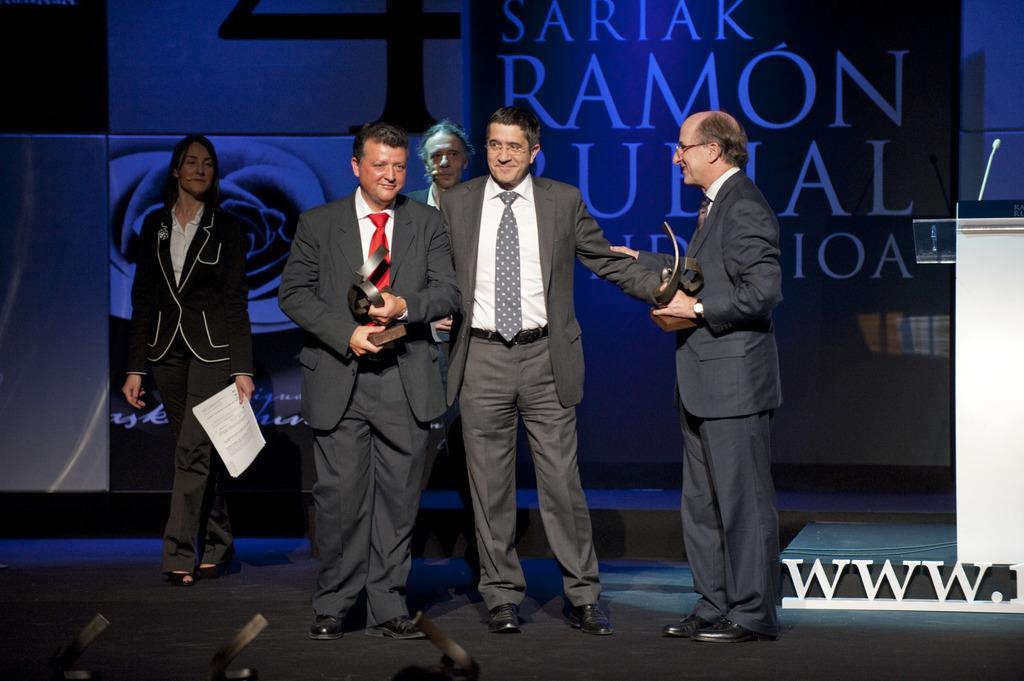How would you summarize this image in a sentence or two? In this image we can see people holding an object and we can also see a podium and a board with some text. 